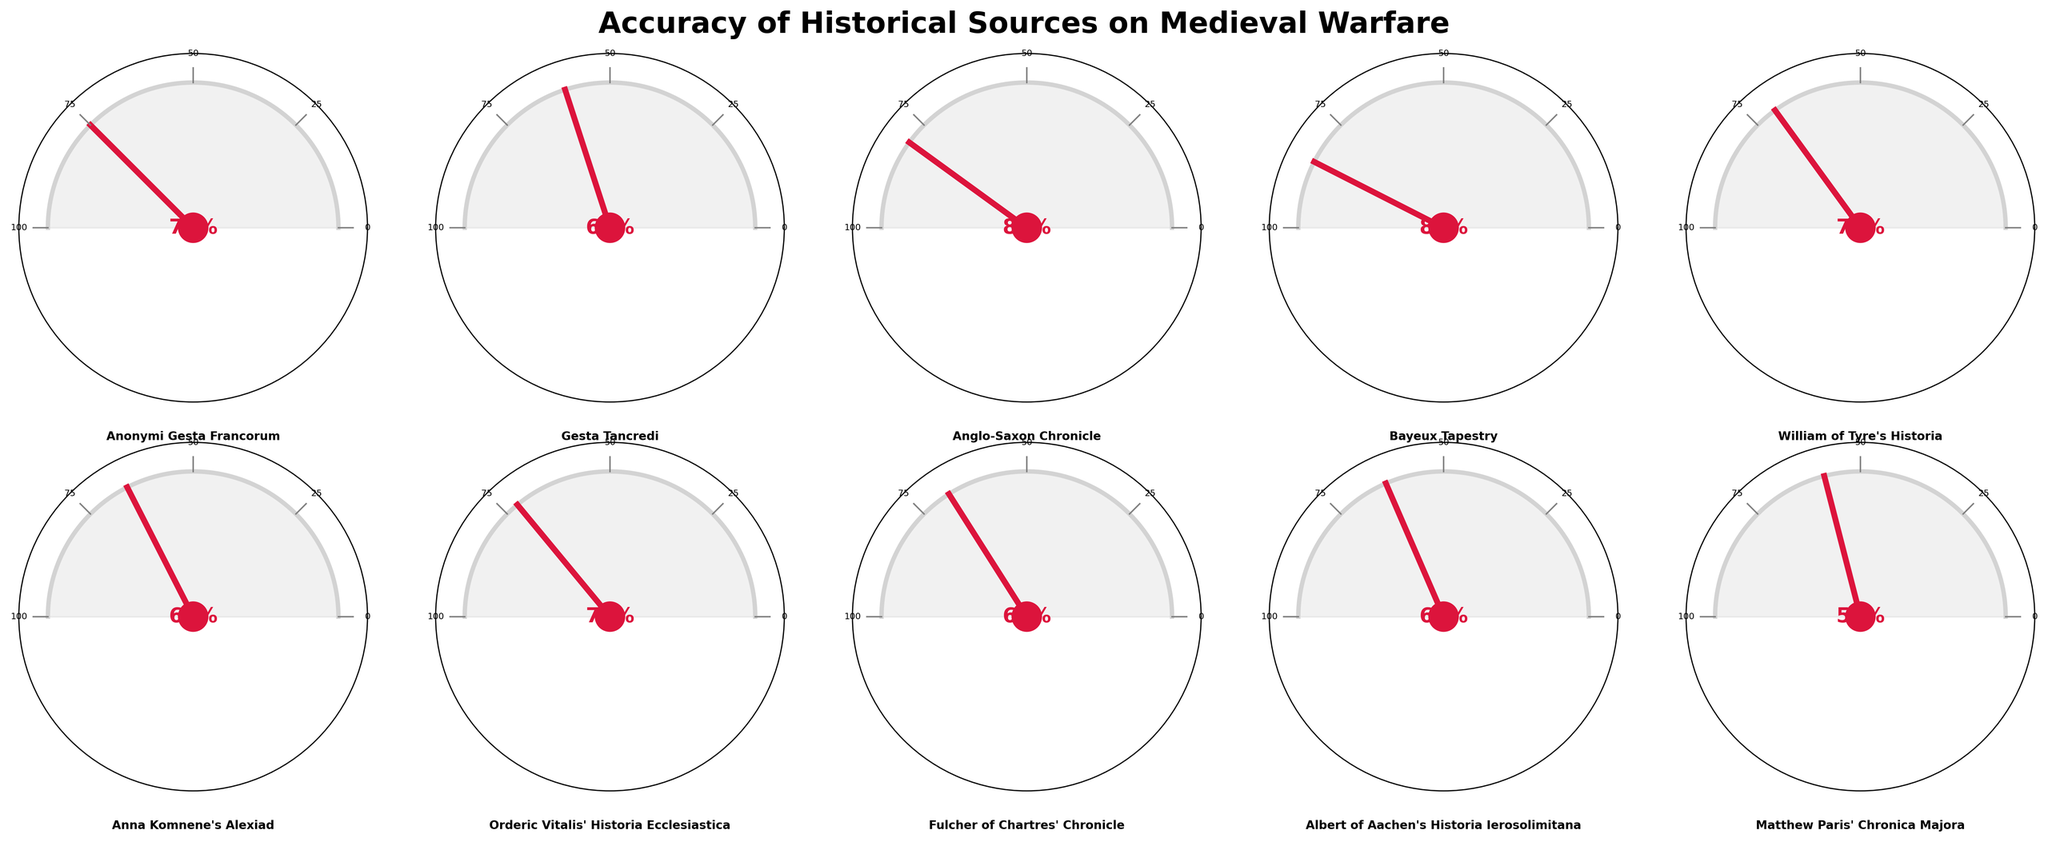What is the title of the figure? The title is located at the top of the figure and reads "Accuracy of Historical Sources on Medieval Warfare."
Answer: Accuracy of Historical Sources on Medieval Warfare Which historical source has the highest accuracy? By looking at the gauge charts, the source with the highest accuracy has the needle pointing closest to the maximum mark. The Bayeux Tapestry has an accuracy of 85%, which is the highest among the sources listed.
Answer: Bayeux Tapestry What is the combined accuracy of Gesta Tancredi and Anna Komnene's Alexiad? First, locate the accuracy values for both sources. Gesta Tancredi has an accuracy of 60%, and Anna Komnene's Alexiad has an accuracy of 65%. Adding these accuracies together results in 60 + 65 = 125.
Answer: 125 Which source has an accuracy closest to 70%? By examining the accuracy values displayed on each gauge chart, William of Tyre's Historia has an accuracy of 70%, which is the closest to 70%.
Answer: William of Tyre's Historia How many sources have an accuracy of 70% or higher? Count the number of sources with accuracy values of 70% or more. These sources are Anonymi Gesta Francorum (75%), Anglo-Saxon Chronicle (80%), Bayeux Tapestry (85%), William of Tyre's Historia (70%), and Orderic Vitalis' Historia Ecclesiastica (72%). There are five sources meeting this criterion.
Answer: 5 Which source has the lowest accuracy rating? Identify the gauge chart with the needle pointing to the lowest value. Matthew Paris' Chronica Majora has the lowest accuracy of 58%.
Answer: Matthew Paris' Chronica Majora What is the difference in accuracy between Anonymi Gesta Francorum and Albert of Aachen's Historia Ierosolimitana? Subtract the accuracy of Albert of Aachen's Historia Ierosolimitana (63%) from Anonymi Gesta Francorum (75%). The difference is 75 - 63 = 12.
Answer: 12 What is the average accuracy of the listed historical sources? Sum the accuracy values of all sources and divide by the number of sources. The sum is 75 + 60 + 80 + 85 + 70 + 65 + 72 + 68 + 63 + 58 = 696, dividing by 10 gives an average of 696/10 = 69.6.
Answer: 69.6 